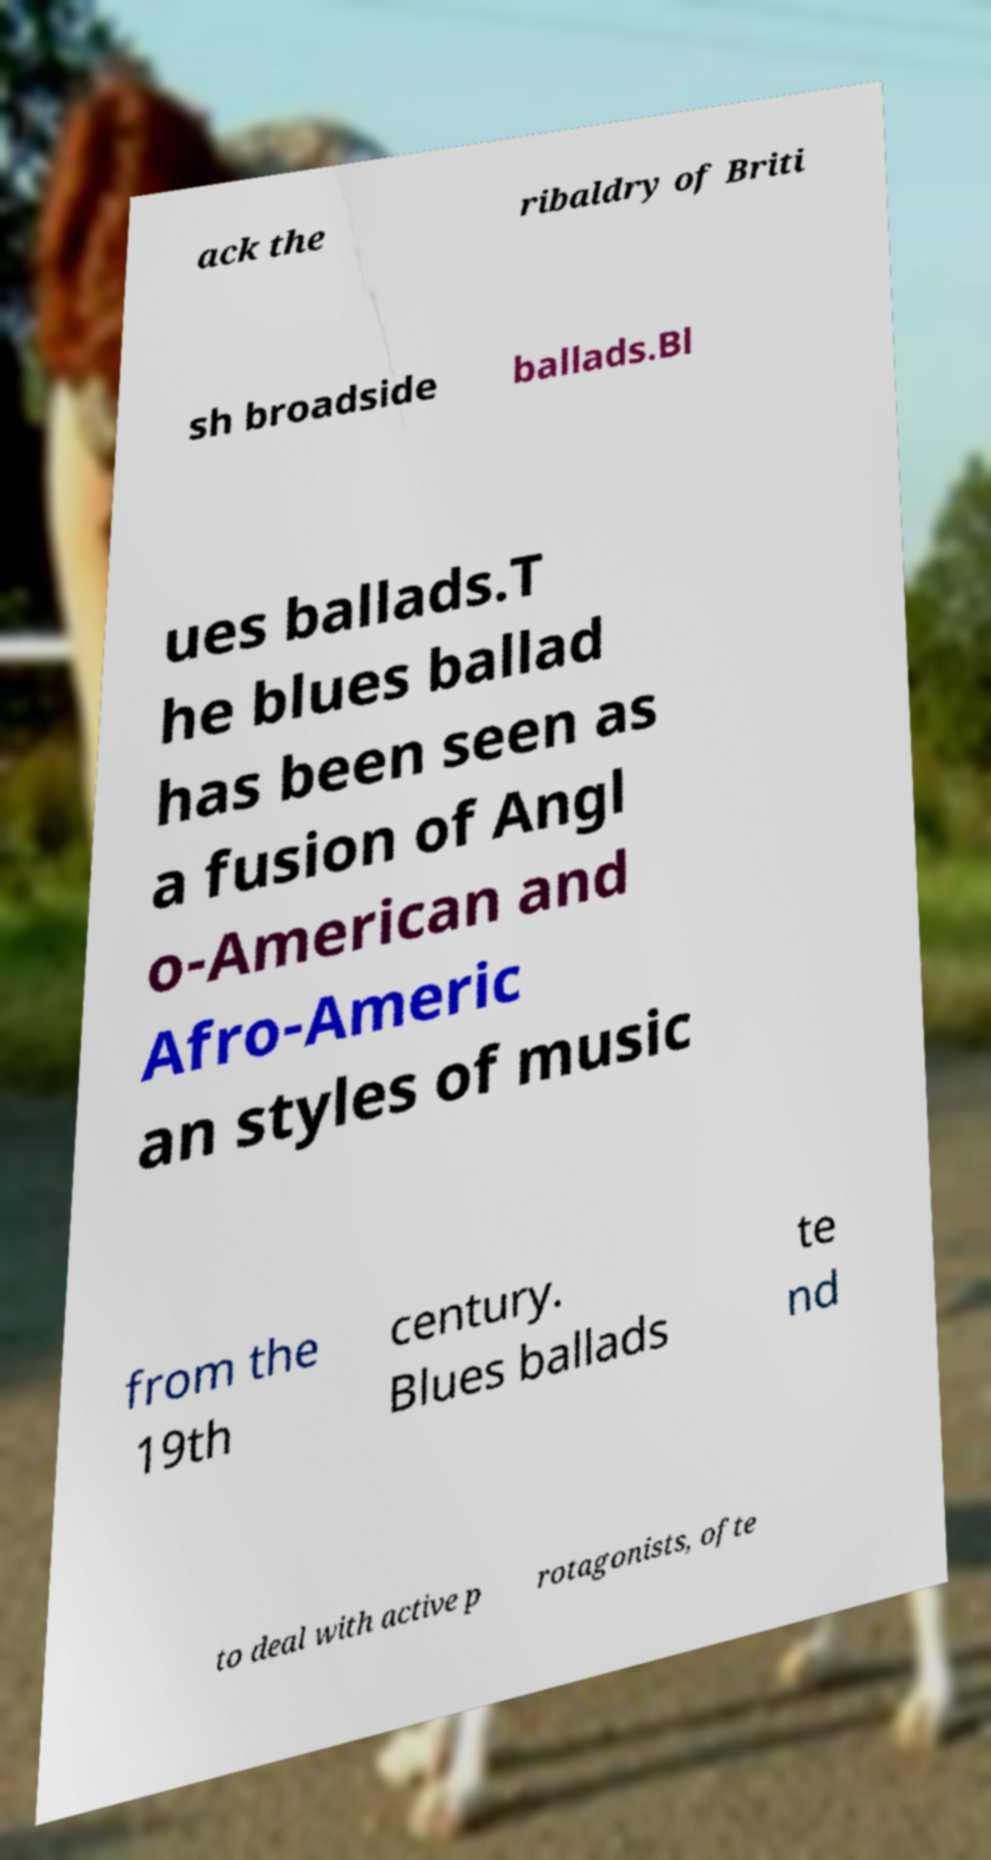I need the written content from this picture converted into text. Can you do that? ack the ribaldry of Briti sh broadside ballads.Bl ues ballads.T he blues ballad has been seen as a fusion of Angl o-American and Afro-Americ an styles of music from the 19th century. Blues ballads te nd to deal with active p rotagonists, ofte 